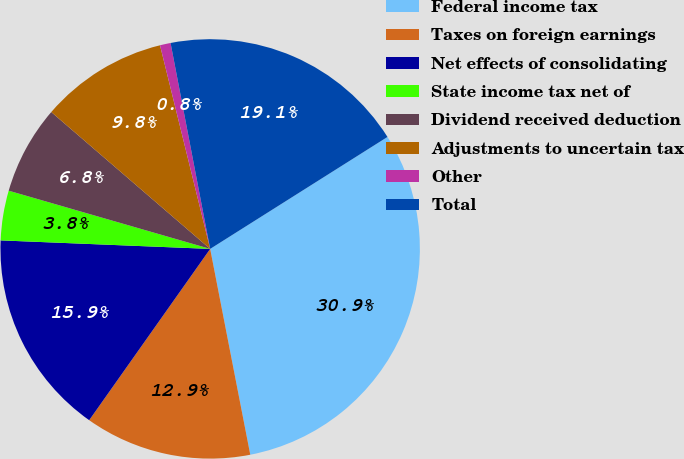Convert chart. <chart><loc_0><loc_0><loc_500><loc_500><pie_chart><fcel>Federal income tax<fcel>Taxes on foreign earnings<fcel>Net effects of consolidating<fcel>State income tax net of<fcel>Dividend received deduction<fcel>Adjustments to uncertain tax<fcel>Other<fcel>Total<nl><fcel>30.9%<fcel>12.85%<fcel>15.86%<fcel>3.83%<fcel>6.84%<fcel>9.84%<fcel>0.82%<fcel>19.06%<nl></chart> 